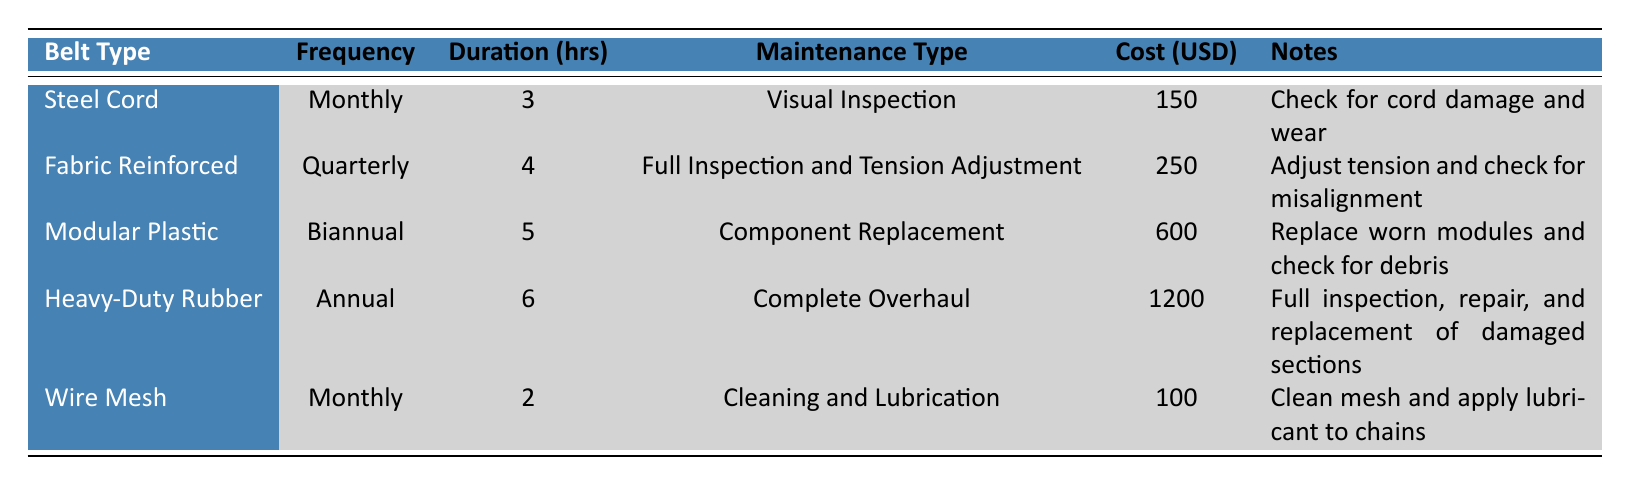What is the maintenance type for the Heavy-Duty Rubber Conveyor Belt? From the table, we can directly look under the "Maintenance Type" column for the row corresponding to "Heavy-Duty Rubber." It states that the maintenance type is "Complete Overhaul."
Answer: Complete Overhaul How often is the Steel Cord Conveyor Belt inspected? The inspection frequency for the Steel Cord Conveyor Belt is found in the "Frequency" column of its respective row, which indicates it is inspected "Monthly."
Answer: Monthly What is the total average cost for all types of conveyor belt maintenance? To find the total average cost, we sum up the costs from the "Cost (USD)" column: 150 + 250 + 600 + 1200 + 100 = 2300. Therefore, the average cost is calculated as 2300 divided by 5, which equals 460.
Answer: 460 Is the inspection duration for the Modular Plastic Conveyor Belt more than 4 hours? Looking at the "Duration (hrs)" column for Modular Plastic, the inspection duration is 5 hours. Thus, it is indeed more than 4 hours.
Answer: Yes What is the maintenance cost for the Wire Mesh Conveyor Belt compared to the Fabric Reinforced Conveyor Belt? The costs for Wire Mesh and Fabric Reinforced are 100 and 250 respectively. To compare, we can see that 100 is less than 250. Therefore, the Wire Mesh Conveyor Belt is cheaper.
Answer: Wire Mesh is cheaper 